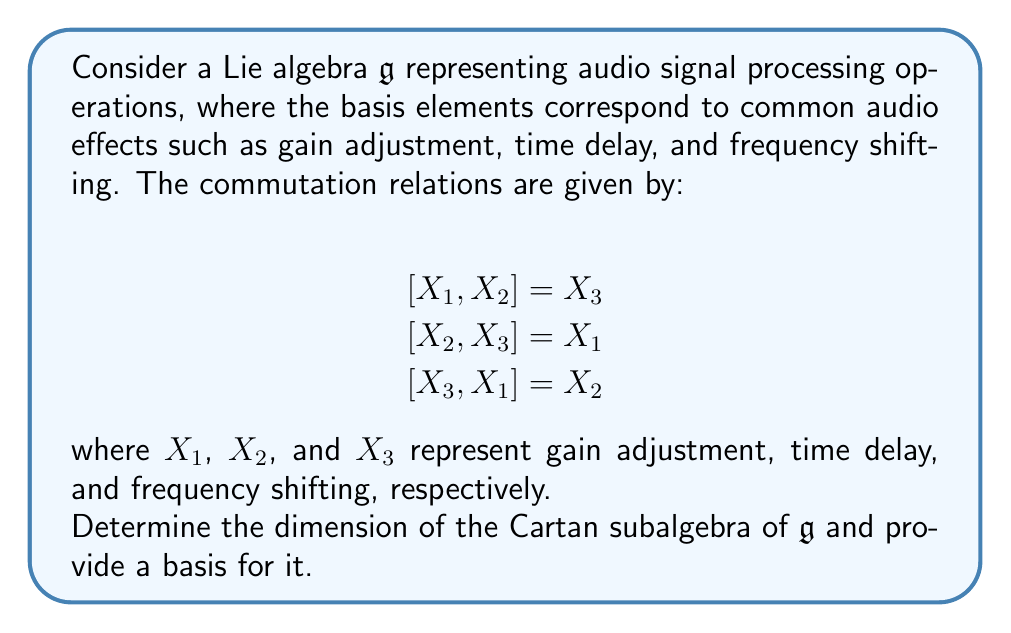Show me your answer to this math problem. To analyze the Cartan subalgebra of this Lie algebra, we need to follow these steps:

1) First, recall that a Cartan subalgebra is a maximal abelian subalgebra of $\mathfrak{g}$ whose elements are ad-diagonalizable.

2) In this case, we have a 3-dimensional Lie algebra with the given commutation relations. These relations are actually isomorphic to the special orthogonal Lie algebra $\mathfrak{so}(3)$.

3) For $\mathfrak{so}(3)$, the Cartan subalgebra is 1-dimensional. This is because $\mathfrak{so}(3)$ is a simple Lie algebra of rank 1.

4) To find a basis for the Cartan subalgebra, we need to find an element that commutes with itself but not with the other basis elements. Let's try a general element:

   $$H = aX_1 + bX_2 + cX_3$$

5) For $H$ to be in the Cartan subalgebra, it must satisfy:

   $$[H, X_1] = [H, X_2] = [H, X_3] = 0$$

6) Calculating these commutators:

   $$[H, X_1] = b[X_2, X_1] + c[X_3, X_1] = -bX_3 + cX_2$$
   $$[H, X_2] = a[X_1, X_2] + c[X_3, X_2] = aX_3 - cX_1$$
   $$[H, X_3] = a[X_1, X_3] + b[X_2, X_3] = -aX_2 + bX_1$$

7) For these to all be zero, we must have $a = b = c = 0$. This means there is no non-zero element that commutes with all basis elements.

8) However, any non-zero linear combination of $X_1$, $X_2$, and $X_3$ will generate a 1-dimensional Cartan subalgebra. For simplicity, we can choose $X_1$ as the basis for our Cartan subalgebra.

Thus, the Cartan subalgebra is 1-dimensional, and we can choose $X_1$ (representing gain adjustment in our audio processing context) as its basis.
Answer: The dimension of the Cartan subalgebra is 1, and a basis for it is $\{X_1\}$. 